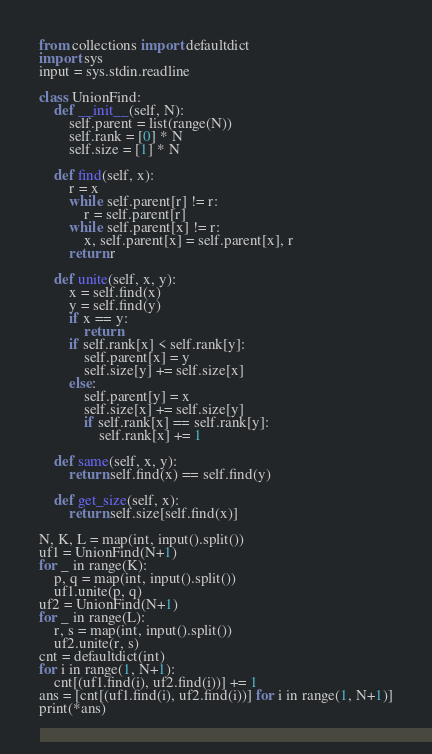Convert code to text. <code><loc_0><loc_0><loc_500><loc_500><_Python_>from collections import defaultdict
import sys
input = sys.stdin.readline

class UnionFind:
    def __init__(self, N):
        self.parent = list(range(N))
        self.rank = [0] * N
        self.size = [1] * N

    def find(self, x):
        r = x
        while self.parent[r] != r:
            r = self.parent[r]
        while self.parent[x] != r:
            x, self.parent[x] = self.parent[x], r
        return r

    def unite(self, x, y):
        x = self.find(x)
        y = self.find(y)
        if x == y:
            return
        if self.rank[x] < self.rank[y]:
            self.parent[x] = y
            self.size[y] += self.size[x]
        else:
            self.parent[y] = x
            self.size[x] += self.size[y]
            if self.rank[x] == self.rank[y]:
                self.rank[x] += 1

    def same(self, x, y):
        return self.find(x) == self.find(y)

    def get_size(self, x):
        return self.size[self.find(x)]

N, K, L = map(int, input().split())
uf1 = UnionFind(N+1)
for _ in range(K):
    p, q = map(int, input().split())
    uf1.unite(p, q)
uf2 = UnionFind(N+1)
for _ in range(L):
    r, s = map(int, input().split())
    uf2.unite(r, s)
cnt = defaultdict(int)
for i in range(1, N+1):
    cnt[(uf1.find(i), uf2.find(i))] += 1
ans = [cnt[(uf1.find(i), uf2.find(i))] for i in range(1, N+1)]
print(*ans)</code> 